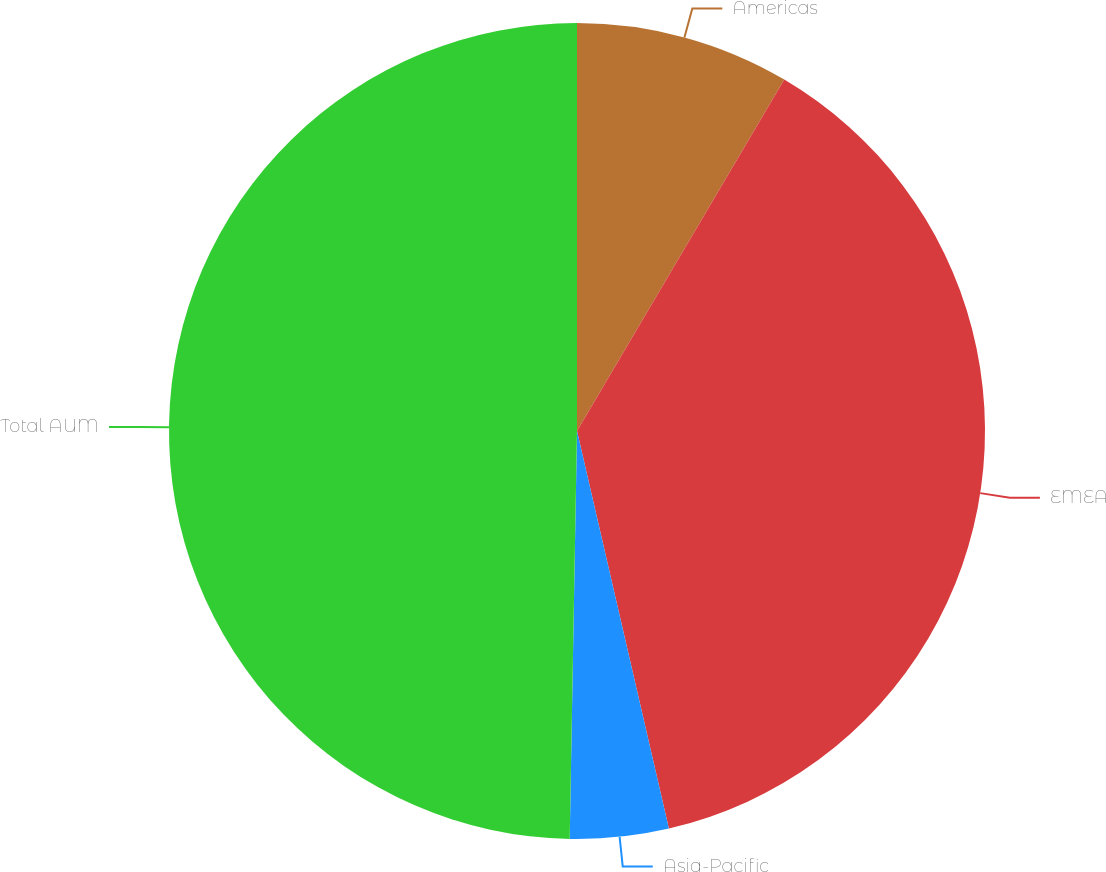Convert chart to OTSL. <chart><loc_0><loc_0><loc_500><loc_500><pie_chart><fcel>Americas<fcel>EMEA<fcel>Asia-Pacific<fcel>Total AUM<nl><fcel>8.48%<fcel>37.9%<fcel>3.9%<fcel>49.71%<nl></chart> 